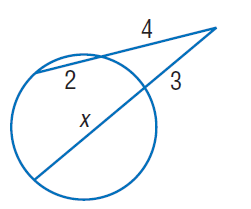Question: Find x. Round to the nearest tenth if necessary. Assume that segments that appear to be tangent are tangent.
Choices:
A. 2
B. 3
C. 4
D. 5
Answer with the letter. Answer: D 